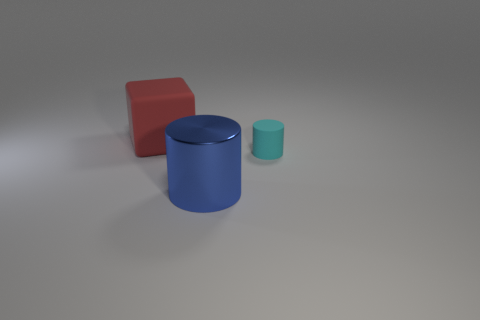What could be the possible size of these cylinders? Based on the perspective and assuming a standard studio environment, the larger blue cylinder could be about a foot in height, whereas the smaller teal cylinder might be roughly half that size. 